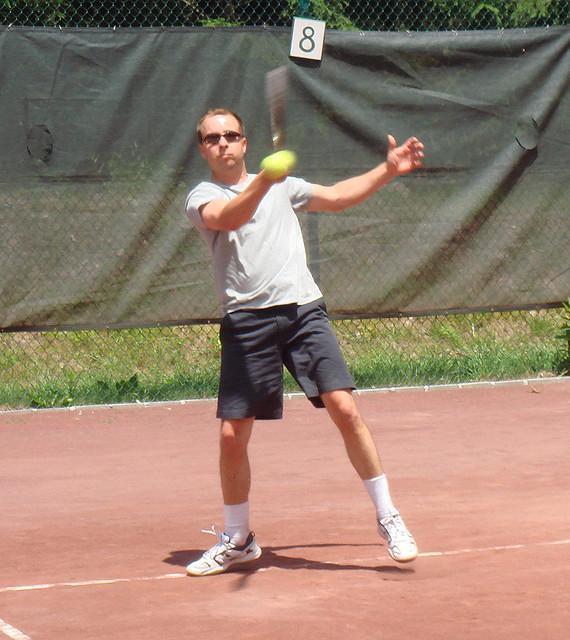Why is the man wearing glasses?
Select the accurate response from the four choices given to answer the question.
Options: Fashion, dress code, block sunlight, halloween costume. Block sunlight. 